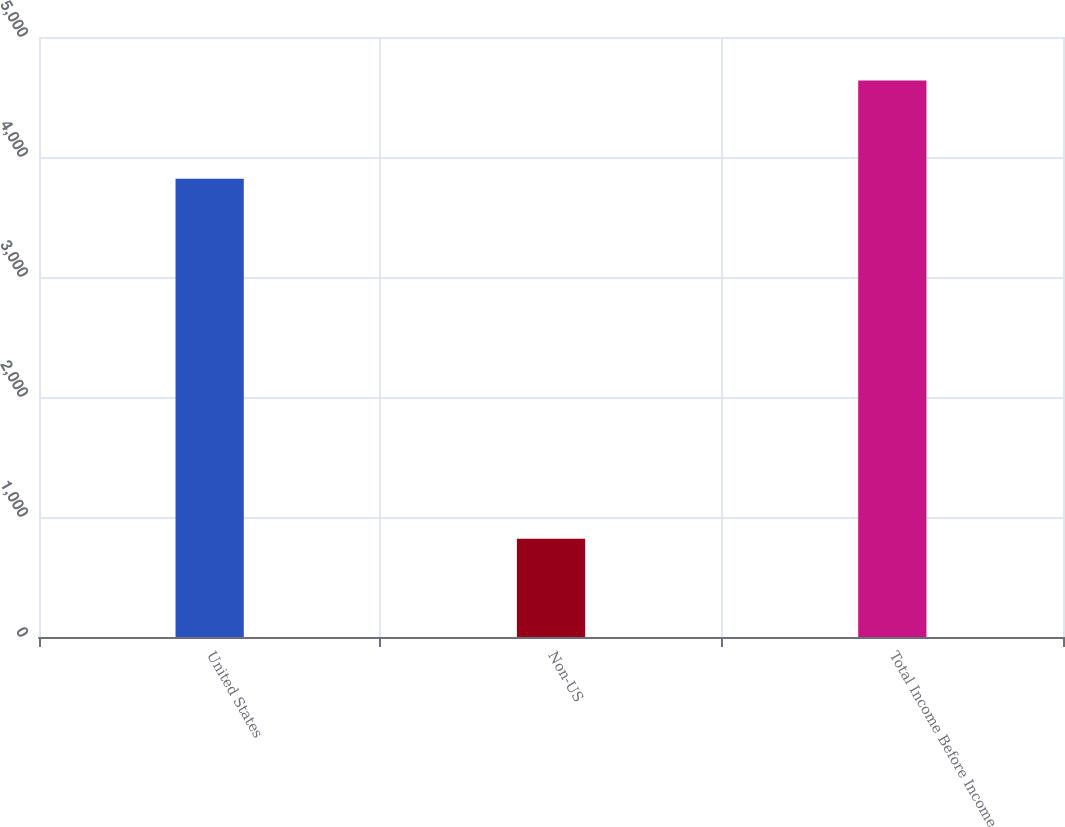Convert chart to OTSL. <chart><loc_0><loc_0><loc_500><loc_500><bar_chart><fcel>United States<fcel>Non-US<fcel>Total Income Before Income<nl><fcel>3819<fcel>818<fcel>4637<nl></chart> 